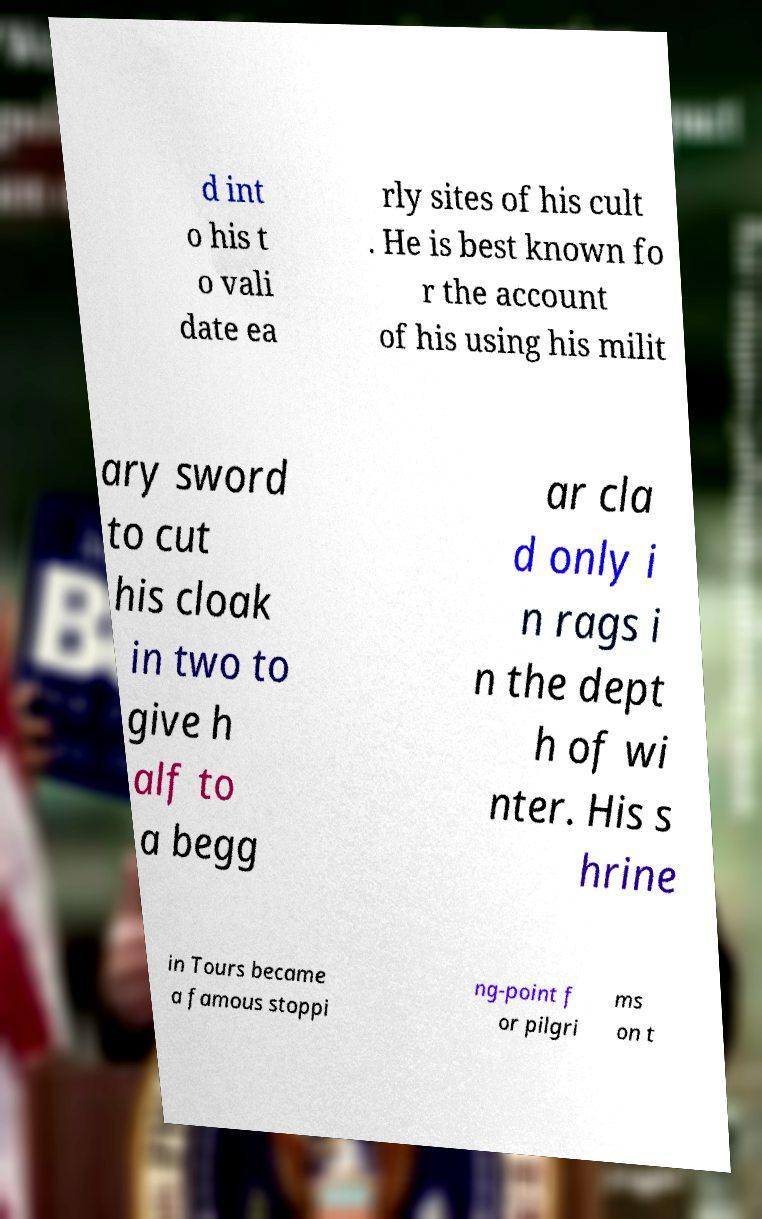Could you extract and type out the text from this image? d int o his t o vali date ea rly sites of his cult . He is best known fo r the account of his using his milit ary sword to cut his cloak in two to give h alf to a begg ar cla d only i n rags i n the dept h of wi nter. His s hrine in Tours became a famous stoppi ng-point f or pilgri ms on t 